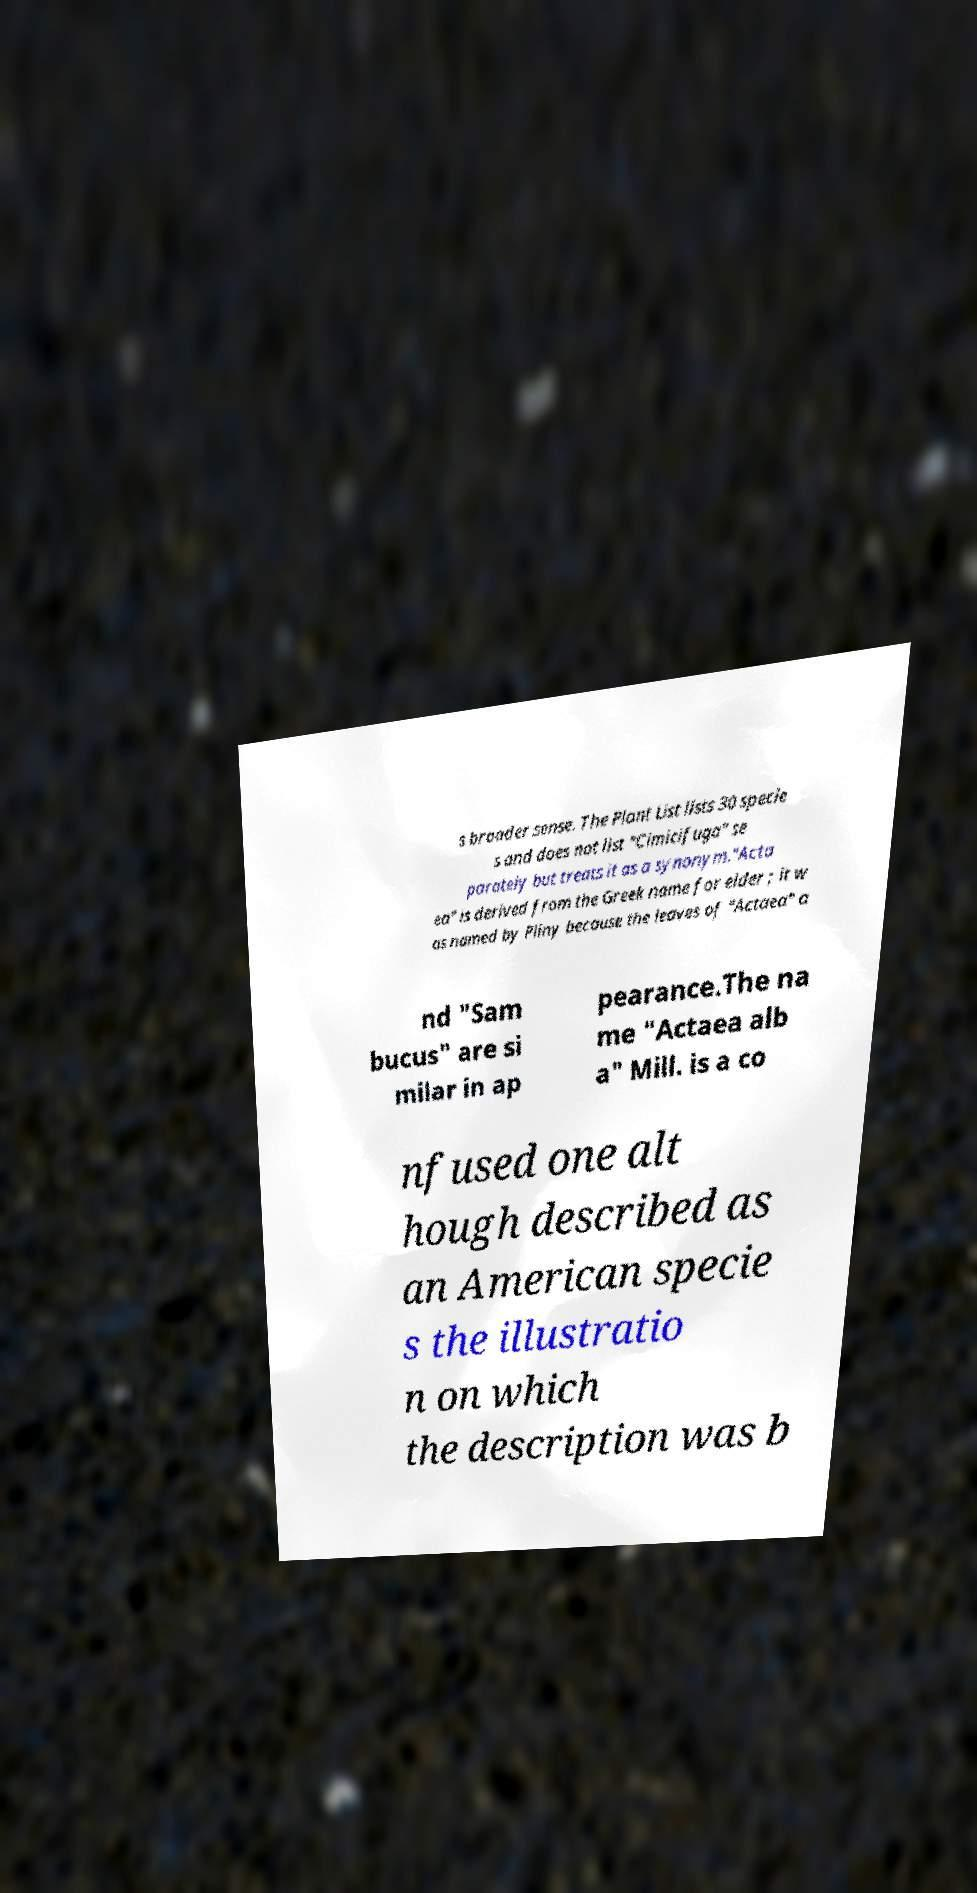Could you assist in decoding the text presented in this image and type it out clearly? s broader sense. The Plant List lists 30 specie s and does not list "Cimicifuga" se parately but treats it as a synonym."Acta ea" is derived from the Greek name for elder ; it w as named by Pliny because the leaves of "Actaea" a nd "Sam bucus" are si milar in ap pearance.The na me "Actaea alb a" Mill. is a co nfused one alt hough described as an American specie s the illustratio n on which the description was b 